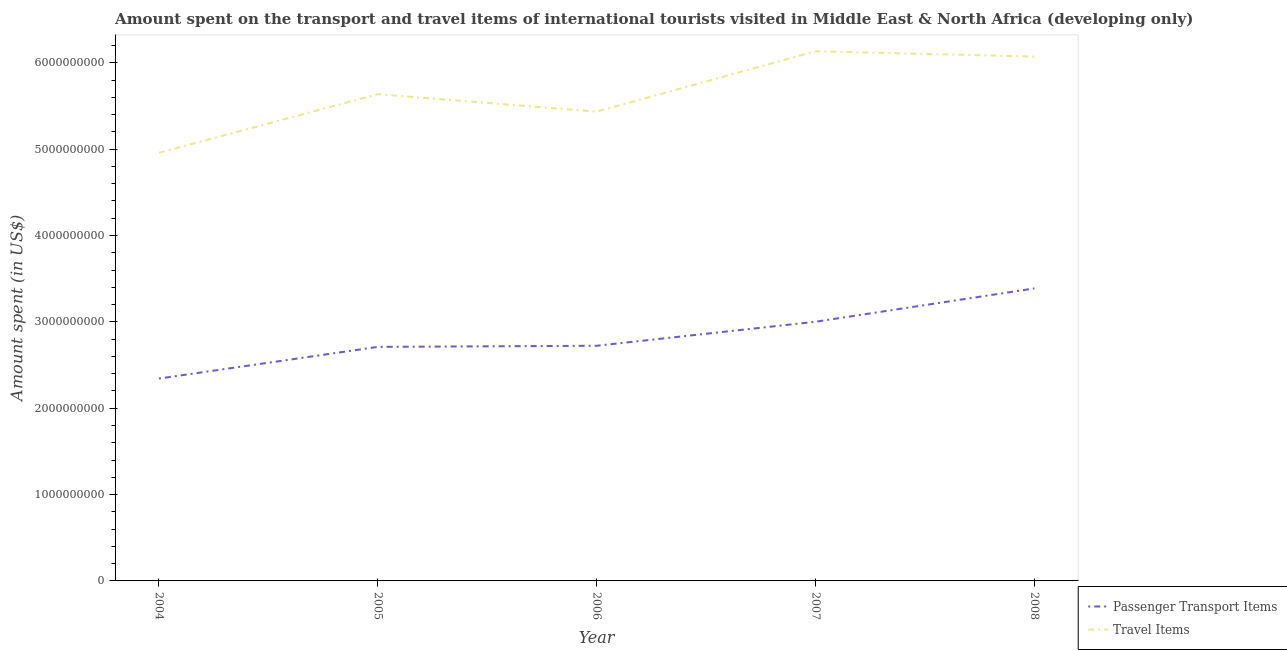Does the line corresponding to amount spent on passenger transport items intersect with the line corresponding to amount spent in travel items?
Make the answer very short. No. What is the amount spent in travel items in 2004?
Provide a short and direct response. 4.96e+09. Across all years, what is the maximum amount spent in travel items?
Offer a terse response. 6.13e+09. Across all years, what is the minimum amount spent on passenger transport items?
Give a very brief answer. 2.34e+09. In which year was the amount spent on passenger transport items maximum?
Your answer should be compact. 2008. What is the total amount spent in travel items in the graph?
Offer a very short reply. 2.82e+1. What is the difference between the amount spent in travel items in 2006 and that in 2008?
Offer a very short reply. -6.38e+08. What is the difference between the amount spent in travel items in 2008 and the amount spent on passenger transport items in 2005?
Provide a succinct answer. 3.36e+09. What is the average amount spent on passenger transport items per year?
Your answer should be compact. 2.83e+09. In the year 2005, what is the difference between the amount spent in travel items and amount spent on passenger transport items?
Ensure brevity in your answer.  2.93e+09. What is the ratio of the amount spent in travel items in 2004 to that in 2007?
Your response must be concise. 0.81. Is the amount spent on passenger transport items in 2004 less than that in 2006?
Your answer should be compact. Yes. Is the difference between the amount spent on passenger transport items in 2004 and 2006 greater than the difference between the amount spent in travel items in 2004 and 2006?
Keep it short and to the point. Yes. What is the difference between the highest and the second highest amount spent on passenger transport items?
Provide a short and direct response. 3.86e+08. What is the difference between the highest and the lowest amount spent in travel items?
Offer a terse response. 1.18e+09. In how many years, is the amount spent in travel items greater than the average amount spent in travel items taken over all years?
Your response must be concise. 2. Is the amount spent in travel items strictly greater than the amount spent on passenger transport items over the years?
Give a very brief answer. Yes. How many lines are there?
Make the answer very short. 2. How many years are there in the graph?
Provide a short and direct response. 5. Are the values on the major ticks of Y-axis written in scientific E-notation?
Provide a succinct answer. No. Does the graph contain grids?
Provide a short and direct response. No. Where does the legend appear in the graph?
Offer a very short reply. Bottom right. How many legend labels are there?
Your answer should be compact. 2. How are the legend labels stacked?
Keep it short and to the point. Vertical. What is the title of the graph?
Provide a succinct answer. Amount spent on the transport and travel items of international tourists visited in Middle East & North Africa (developing only). Does "Male labourers" appear as one of the legend labels in the graph?
Provide a short and direct response. No. What is the label or title of the Y-axis?
Offer a very short reply. Amount spent (in US$). What is the Amount spent (in US$) in Passenger Transport Items in 2004?
Ensure brevity in your answer.  2.34e+09. What is the Amount spent (in US$) of Travel Items in 2004?
Provide a short and direct response. 4.96e+09. What is the Amount spent (in US$) of Passenger Transport Items in 2005?
Make the answer very short. 2.71e+09. What is the Amount spent (in US$) of Travel Items in 2005?
Make the answer very short. 5.64e+09. What is the Amount spent (in US$) in Passenger Transport Items in 2006?
Give a very brief answer. 2.72e+09. What is the Amount spent (in US$) in Travel Items in 2006?
Your answer should be compact. 5.44e+09. What is the Amount spent (in US$) of Passenger Transport Items in 2007?
Provide a short and direct response. 3.00e+09. What is the Amount spent (in US$) of Travel Items in 2007?
Offer a terse response. 6.13e+09. What is the Amount spent (in US$) of Passenger Transport Items in 2008?
Your answer should be compact. 3.39e+09. What is the Amount spent (in US$) in Travel Items in 2008?
Your answer should be very brief. 6.07e+09. Across all years, what is the maximum Amount spent (in US$) in Passenger Transport Items?
Offer a very short reply. 3.39e+09. Across all years, what is the maximum Amount spent (in US$) in Travel Items?
Offer a terse response. 6.13e+09. Across all years, what is the minimum Amount spent (in US$) of Passenger Transport Items?
Your answer should be very brief. 2.34e+09. Across all years, what is the minimum Amount spent (in US$) of Travel Items?
Keep it short and to the point. 4.96e+09. What is the total Amount spent (in US$) of Passenger Transport Items in the graph?
Ensure brevity in your answer.  1.42e+1. What is the total Amount spent (in US$) of Travel Items in the graph?
Provide a succinct answer. 2.82e+1. What is the difference between the Amount spent (in US$) of Passenger Transport Items in 2004 and that in 2005?
Your response must be concise. -3.67e+08. What is the difference between the Amount spent (in US$) in Travel Items in 2004 and that in 2005?
Keep it short and to the point. -6.79e+08. What is the difference between the Amount spent (in US$) in Passenger Transport Items in 2004 and that in 2006?
Ensure brevity in your answer.  -3.80e+08. What is the difference between the Amount spent (in US$) in Travel Items in 2004 and that in 2006?
Offer a very short reply. -4.77e+08. What is the difference between the Amount spent (in US$) of Passenger Transport Items in 2004 and that in 2007?
Your response must be concise. -6.58e+08. What is the difference between the Amount spent (in US$) of Travel Items in 2004 and that in 2007?
Your response must be concise. -1.18e+09. What is the difference between the Amount spent (in US$) of Passenger Transport Items in 2004 and that in 2008?
Your answer should be compact. -1.04e+09. What is the difference between the Amount spent (in US$) of Travel Items in 2004 and that in 2008?
Your answer should be very brief. -1.11e+09. What is the difference between the Amount spent (in US$) in Passenger Transport Items in 2005 and that in 2006?
Your answer should be very brief. -1.30e+07. What is the difference between the Amount spent (in US$) in Travel Items in 2005 and that in 2006?
Ensure brevity in your answer.  2.02e+08. What is the difference between the Amount spent (in US$) of Passenger Transport Items in 2005 and that in 2007?
Your answer should be compact. -2.91e+08. What is the difference between the Amount spent (in US$) in Travel Items in 2005 and that in 2007?
Ensure brevity in your answer.  -4.97e+08. What is the difference between the Amount spent (in US$) in Passenger Transport Items in 2005 and that in 2008?
Make the answer very short. -6.77e+08. What is the difference between the Amount spent (in US$) in Travel Items in 2005 and that in 2008?
Make the answer very short. -4.36e+08. What is the difference between the Amount spent (in US$) in Passenger Transport Items in 2006 and that in 2007?
Provide a short and direct response. -2.78e+08. What is the difference between the Amount spent (in US$) of Travel Items in 2006 and that in 2007?
Offer a very short reply. -6.99e+08. What is the difference between the Amount spent (in US$) of Passenger Transport Items in 2006 and that in 2008?
Offer a terse response. -6.64e+08. What is the difference between the Amount spent (in US$) in Travel Items in 2006 and that in 2008?
Your response must be concise. -6.38e+08. What is the difference between the Amount spent (in US$) of Passenger Transport Items in 2007 and that in 2008?
Give a very brief answer. -3.86e+08. What is the difference between the Amount spent (in US$) in Travel Items in 2007 and that in 2008?
Make the answer very short. 6.17e+07. What is the difference between the Amount spent (in US$) in Passenger Transport Items in 2004 and the Amount spent (in US$) in Travel Items in 2005?
Your response must be concise. -3.29e+09. What is the difference between the Amount spent (in US$) in Passenger Transport Items in 2004 and the Amount spent (in US$) in Travel Items in 2006?
Make the answer very short. -3.09e+09. What is the difference between the Amount spent (in US$) of Passenger Transport Items in 2004 and the Amount spent (in US$) of Travel Items in 2007?
Give a very brief answer. -3.79e+09. What is the difference between the Amount spent (in US$) of Passenger Transport Items in 2004 and the Amount spent (in US$) of Travel Items in 2008?
Keep it short and to the point. -3.73e+09. What is the difference between the Amount spent (in US$) in Passenger Transport Items in 2005 and the Amount spent (in US$) in Travel Items in 2006?
Provide a short and direct response. -2.72e+09. What is the difference between the Amount spent (in US$) in Passenger Transport Items in 2005 and the Amount spent (in US$) in Travel Items in 2007?
Give a very brief answer. -3.42e+09. What is the difference between the Amount spent (in US$) in Passenger Transport Items in 2005 and the Amount spent (in US$) in Travel Items in 2008?
Offer a terse response. -3.36e+09. What is the difference between the Amount spent (in US$) of Passenger Transport Items in 2006 and the Amount spent (in US$) of Travel Items in 2007?
Offer a very short reply. -3.41e+09. What is the difference between the Amount spent (in US$) in Passenger Transport Items in 2006 and the Amount spent (in US$) in Travel Items in 2008?
Provide a succinct answer. -3.35e+09. What is the difference between the Amount spent (in US$) in Passenger Transport Items in 2007 and the Amount spent (in US$) in Travel Items in 2008?
Ensure brevity in your answer.  -3.07e+09. What is the average Amount spent (in US$) of Passenger Transport Items per year?
Your answer should be compact. 2.83e+09. What is the average Amount spent (in US$) of Travel Items per year?
Your answer should be very brief. 5.65e+09. In the year 2004, what is the difference between the Amount spent (in US$) in Passenger Transport Items and Amount spent (in US$) in Travel Items?
Give a very brief answer. -2.61e+09. In the year 2005, what is the difference between the Amount spent (in US$) of Passenger Transport Items and Amount spent (in US$) of Travel Items?
Your answer should be compact. -2.93e+09. In the year 2006, what is the difference between the Amount spent (in US$) of Passenger Transport Items and Amount spent (in US$) of Travel Items?
Offer a terse response. -2.71e+09. In the year 2007, what is the difference between the Amount spent (in US$) in Passenger Transport Items and Amount spent (in US$) in Travel Items?
Give a very brief answer. -3.13e+09. In the year 2008, what is the difference between the Amount spent (in US$) in Passenger Transport Items and Amount spent (in US$) in Travel Items?
Ensure brevity in your answer.  -2.68e+09. What is the ratio of the Amount spent (in US$) of Passenger Transport Items in 2004 to that in 2005?
Your answer should be very brief. 0.86. What is the ratio of the Amount spent (in US$) in Travel Items in 2004 to that in 2005?
Ensure brevity in your answer.  0.88. What is the ratio of the Amount spent (in US$) of Passenger Transport Items in 2004 to that in 2006?
Make the answer very short. 0.86. What is the ratio of the Amount spent (in US$) of Travel Items in 2004 to that in 2006?
Ensure brevity in your answer.  0.91. What is the ratio of the Amount spent (in US$) of Passenger Transport Items in 2004 to that in 2007?
Your response must be concise. 0.78. What is the ratio of the Amount spent (in US$) of Travel Items in 2004 to that in 2007?
Provide a succinct answer. 0.81. What is the ratio of the Amount spent (in US$) of Passenger Transport Items in 2004 to that in 2008?
Ensure brevity in your answer.  0.69. What is the ratio of the Amount spent (in US$) of Travel Items in 2004 to that in 2008?
Offer a terse response. 0.82. What is the ratio of the Amount spent (in US$) in Passenger Transport Items in 2005 to that in 2006?
Provide a short and direct response. 1. What is the ratio of the Amount spent (in US$) of Travel Items in 2005 to that in 2006?
Your answer should be very brief. 1.04. What is the ratio of the Amount spent (in US$) of Passenger Transport Items in 2005 to that in 2007?
Your answer should be very brief. 0.9. What is the ratio of the Amount spent (in US$) in Travel Items in 2005 to that in 2007?
Your response must be concise. 0.92. What is the ratio of the Amount spent (in US$) of Passenger Transport Items in 2005 to that in 2008?
Ensure brevity in your answer.  0.8. What is the ratio of the Amount spent (in US$) of Travel Items in 2005 to that in 2008?
Provide a succinct answer. 0.93. What is the ratio of the Amount spent (in US$) in Passenger Transport Items in 2006 to that in 2007?
Make the answer very short. 0.91. What is the ratio of the Amount spent (in US$) of Travel Items in 2006 to that in 2007?
Keep it short and to the point. 0.89. What is the ratio of the Amount spent (in US$) of Passenger Transport Items in 2006 to that in 2008?
Give a very brief answer. 0.8. What is the ratio of the Amount spent (in US$) of Travel Items in 2006 to that in 2008?
Offer a terse response. 0.9. What is the ratio of the Amount spent (in US$) of Passenger Transport Items in 2007 to that in 2008?
Provide a short and direct response. 0.89. What is the ratio of the Amount spent (in US$) of Travel Items in 2007 to that in 2008?
Provide a succinct answer. 1.01. What is the difference between the highest and the second highest Amount spent (in US$) in Passenger Transport Items?
Your answer should be compact. 3.86e+08. What is the difference between the highest and the second highest Amount spent (in US$) of Travel Items?
Your answer should be very brief. 6.17e+07. What is the difference between the highest and the lowest Amount spent (in US$) in Passenger Transport Items?
Offer a very short reply. 1.04e+09. What is the difference between the highest and the lowest Amount spent (in US$) in Travel Items?
Give a very brief answer. 1.18e+09. 